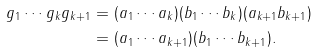Convert formula to latex. <formula><loc_0><loc_0><loc_500><loc_500>g _ { 1 } \cdots g _ { k } g _ { k + 1 } & = ( a _ { 1 } \cdots a _ { k } ) ( b _ { 1 } \cdots b _ { k } ) ( a _ { k + 1 } b _ { k + 1 } ) \\ & = ( a _ { 1 } \cdots a _ { k + 1 } ) ( b _ { 1 } \cdots b _ { k + 1 } ) .</formula> 